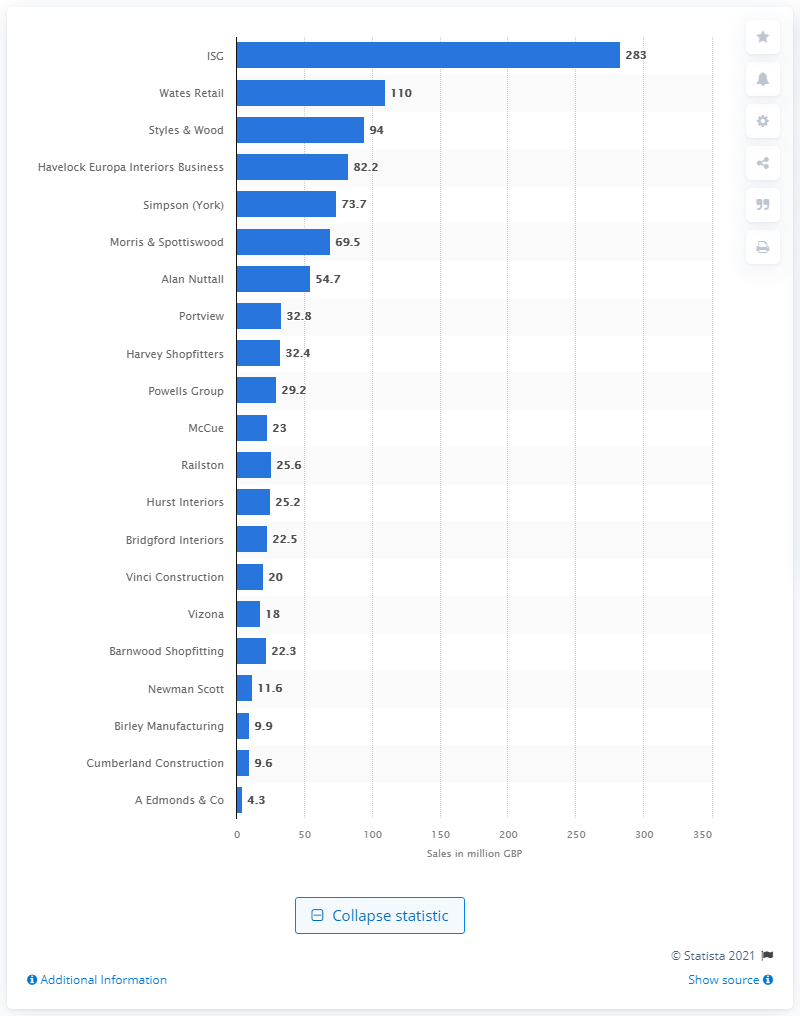Specify some key components in this picture. Wates Retail was the retailer with the highest sales in the UK. 